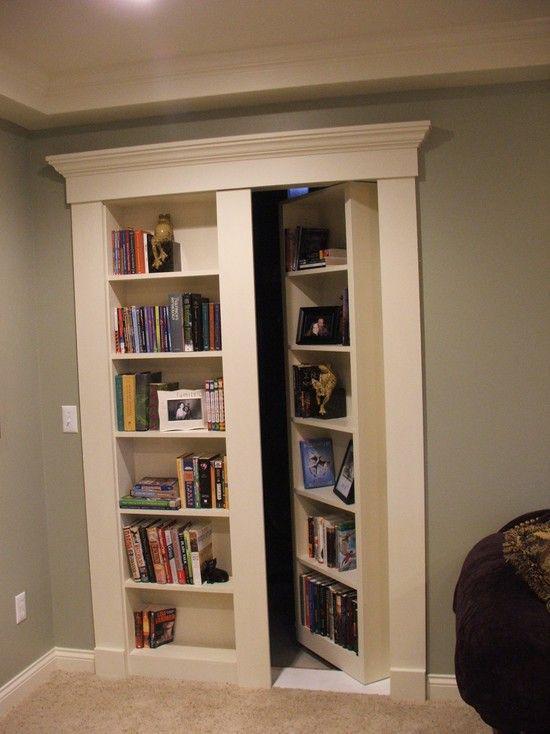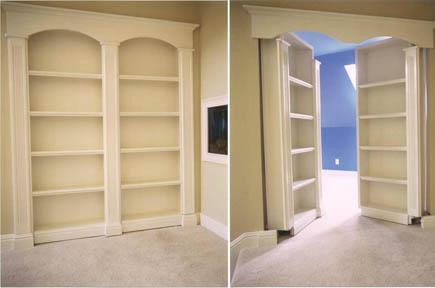The first image is the image on the left, the second image is the image on the right. Given the left and right images, does the statement "There is at least one chair near the bookshelves." hold true? Answer yes or no. No. 